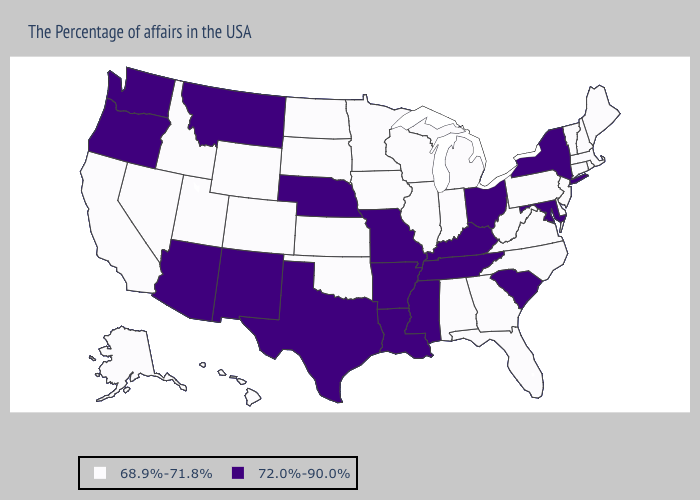What is the value of New Jersey?
Answer briefly. 68.9%-71.8%. Name the states that have a value in the range 68.9%-71.8%?
Answer briefly. Maine, Massachusetts, Rhode Island, New Hampshire, Vermont, Connecticut, New Jersey, Delaware, Pennsylvania, Virginia, North Carolina, West Virginia, Florida, Georgia, Michigan, Indiana, Alabama, Wisconsin, Illinois, Minnesota, Iowa, Kansas, Oklahoma, South Dakota, North Dakota, Wyoming, Colorado, Utah, Idaho, Nevada, California, Alaska, Hawaii. Does the map have missing data?
Keep it brief. No. Which states have the lowest value in the USA?
Concise answer only. Maine, Massachusetts, Rhode Island, New Hampshire, Vermont, Connecticut, New Jersey, Delaware, Pennsylvania, Virginia, North Carolina, West Virginia, Florida, Georgia, Michigan, Indiana, Alabama, Wisconsin, Illinois, Minnesota, Iowa, Kansas, Oklahoma, South Dakota, North Dakota, Wyoming, Colorado, Utah, Idaho, Nevada, California, Alaska, Hawaii. Does Missouri have a lower value than California?
Be succinct. No. Which states have the lowest value in the MidWest?
Quick response, please. Michigan, Indiana, Wisconsin, Illinois, Minnesota, Iowa, Kansas, South Dakota, North Dakota. Name the states that have a value in the range 68.9%-71.8%?
Quick response, please. Maine, Massachusetts, Rhode Island, New Hampshire, Vermont, Connecticut, New Jersey, Delaware, Pennsylvania, Virginia, North Carolina, West Virginia, Florida, Georgia, Michigan, Indiana, Alabama, Wisconsin, Illinois, Minnesota, Iowa, Kansas, Oklahoma, South Dakota, North Dakota, Wyoming, Colorado, Utah, Idaho, Nevada, California, Alaska, Hawaii. Name the states that have a value in the range 72.0%-90.0%?
Concise answer only. New York, Maryland, South Carolina, Ohio, Kentucky, Tennessee, Mississippi, Louisiana, Missouri, Arkansas, Nebraska, Texas, New Mexico, Montana, Arizona, Washington, Oregon. Name the states that have a value in the range 72.0%-90.0%?
Answer briefly. New York, Maryland, South Carolina, Ohio, Kentucky, Tennessee, Mississippi, Louisiana, Missouri, Arkansas, Nebraska, Texas, New Mexico, Montana, Arizona, Washington, Oregon. Among the states that border North Carolina , does South Carolina have the lowest value?
Short answer required. No. Name the states that have a value in the range 68.9%-71.8%?
Concise answer only. Maine, Massachusetts, Rhode Island, New Hampshire, Vermont, Connecticut, New Jersey, Delaware, Pennsylvania, Virginia, North Carolina, West Virginia, Florida, Georgia, Michigan, Indiana, Alabama, Wisconsin, Illinois, Minnesota, Iowa, Kansas, Oklahoma, South Dakota, North Dakota, Wyoming, Colorado, Utah, Idaho, Nevada, California, Alaska, Hawaii. How many symbols are there in the legend?
Answer briefly. 2. What is the value of Missouri?
Write a very short answer. 72.0%-90.0%. What is the value of South Carolina?
Write a very short answer. 72.0%-90.0%. 